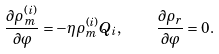<formula> <loc_0><loc_0><loc_500><loc_500>\frac { \partial \rho _ { m } ^ { ( i ) } } { \partial \varphi } = - \eta \rho _ { m } ^ { ( i ) } Q _ { i } , \quad \frac { \partial \rho _ { r } } { \partial \varphi } = 0 .</formula> 